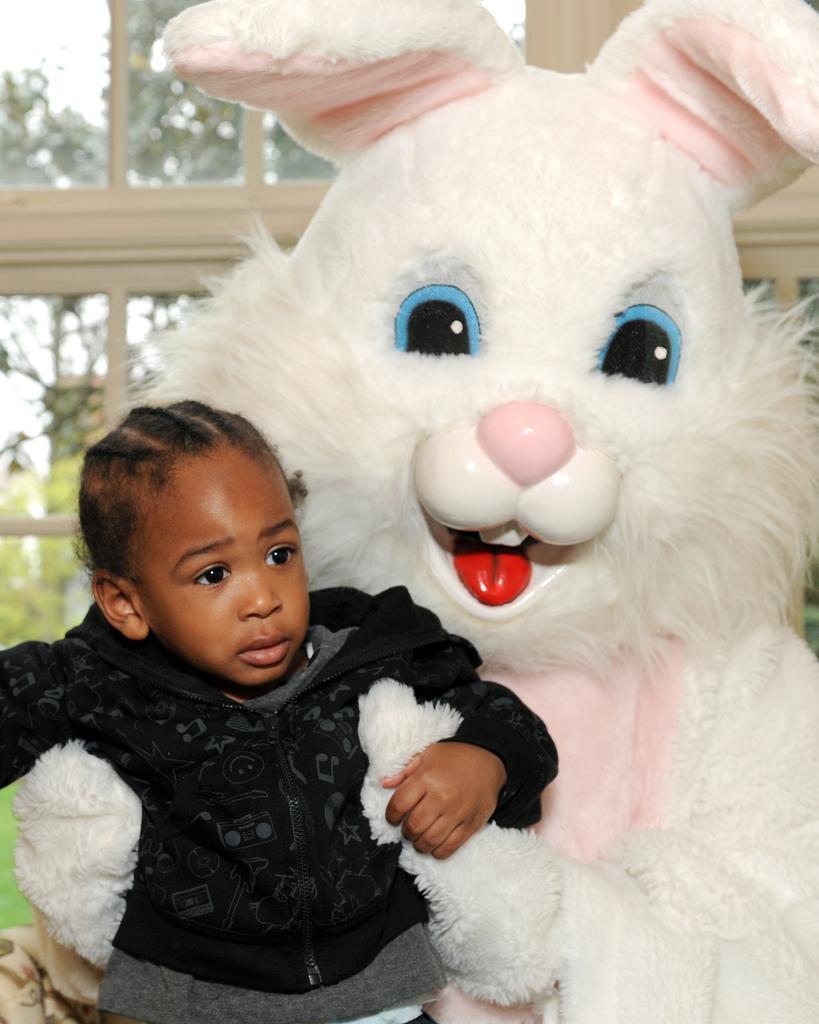Can you describe this image briefly? In the front of the image there is a toy and boy. In the background of the image there are glass windows. Through glass windows we can see trees. 